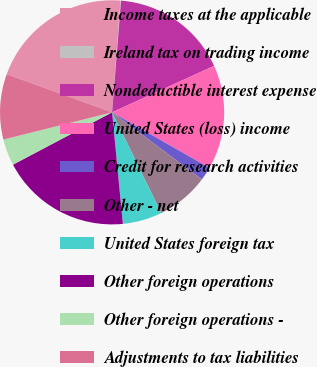Convert chart to OTSL. <chart><loc_0><loc_0><loc_500><loc_500><pie_chart><fcel>Income taxes at the applicable<fcel>Ireland tax on trading income<fcel>Nondeductible interest expense<fcel>United States (loss) income<fcel>Credit for research activities<fcel>Other - net<fcel>United States foreign tax<fcel>Other foreign operations<fcel>Other foreign operations -<fcel>Adjustments to tax liabilities<nl><fcel>20.67%<fcel>0.08%<fcel>16.93%<fcel>15.06%<fcel>1.95%<fcel>7.57%<fcel>5.69%<fcel>18.8%<fcel>3.82%<fcel>9.44%<nl></chart> 